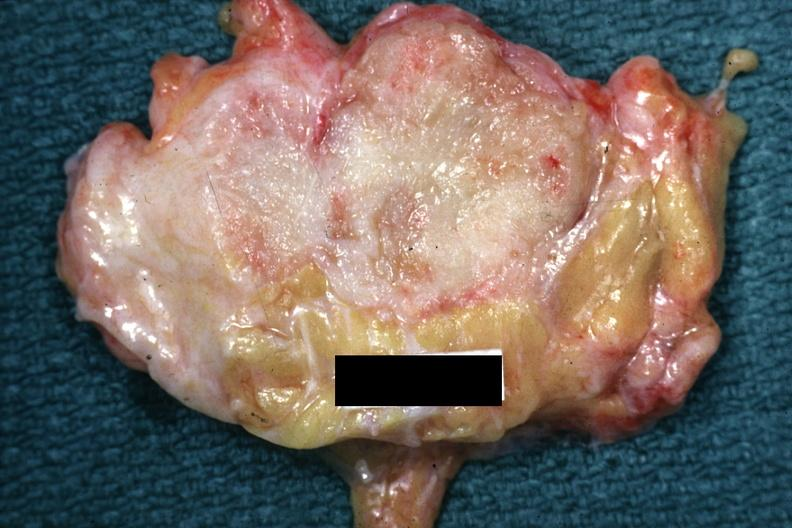s case of peritonitis slide labeled cystosarcoma?
Answer the question using a single word or phrase. No 